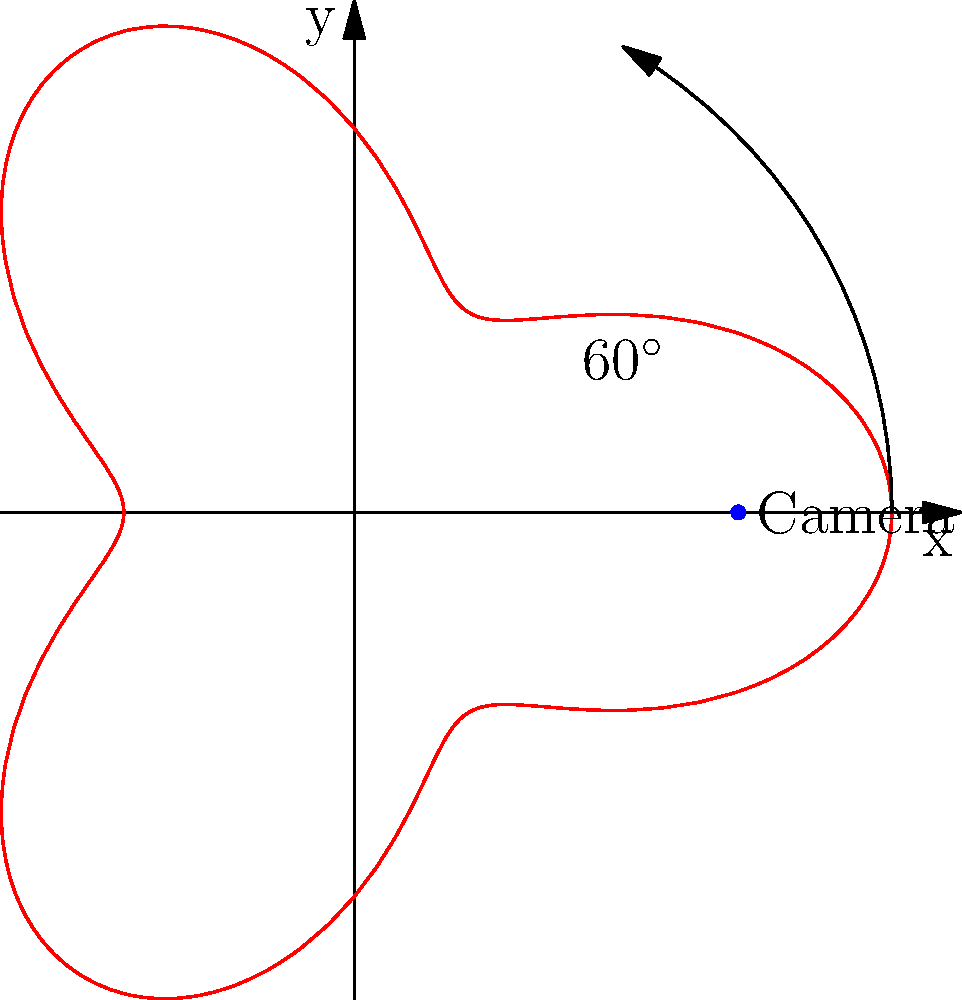As a celebrity walking the red carpet, you want to ensure the perfect camera angle for your photos. The optimal camera positioning follows the polar curve $r = 5 + 2\cos(3\theta)$, where $r$ is in meters. If the camera needs to be placed at a $60^\circ$ angle from the x-axis for the best shot, what is the distance (in meters) between you and the camera? To solve this problem, we need to follow these steps:

1) The polar curve equation is given as $r = 5 + 2\cos(3\theta)$.

2) We need to find $r$ when $\theta = 60^\circ$.

3) First, convert $60^\circ$ to radians:
   $60^\circ = \frac{\pi}{3}$ radians

4) Now, substitute $\theta = \frac{\pi}{3}$ into the equation:
   $r = 5 + 2\cos(3 \cdot \frac{\pi}{3})$

5) Simplify:
   $r = 5 + 2\cos(\pi)$

6) We know that $\cos(\pi) = -1$, so:
   $r = 5 + 2(-1) = 5 - 2 = 3$

Therefore, the distance between you and the camera is 3 meters.
Answer: 3 meters 